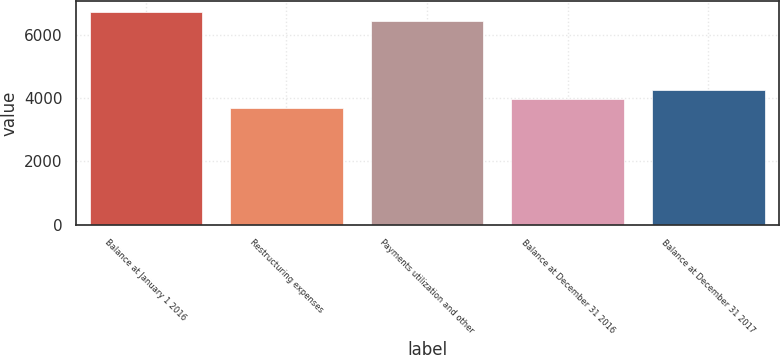Convert chart to OTSL. <chart><loc_0><loc_0><loc_500><loc_500><bar_chart><fcel>Balance at January 1 2016<fcel>Restructuring expenses<fcel>Payments utilization and other<fcel>Balance at December 31 2016<fcel>Balance at December 31 2017<nl><fcel>6713.2<fcel>3674<fcel>6417<fcel>3970.2<fcel>4266.4<nl></chart> 